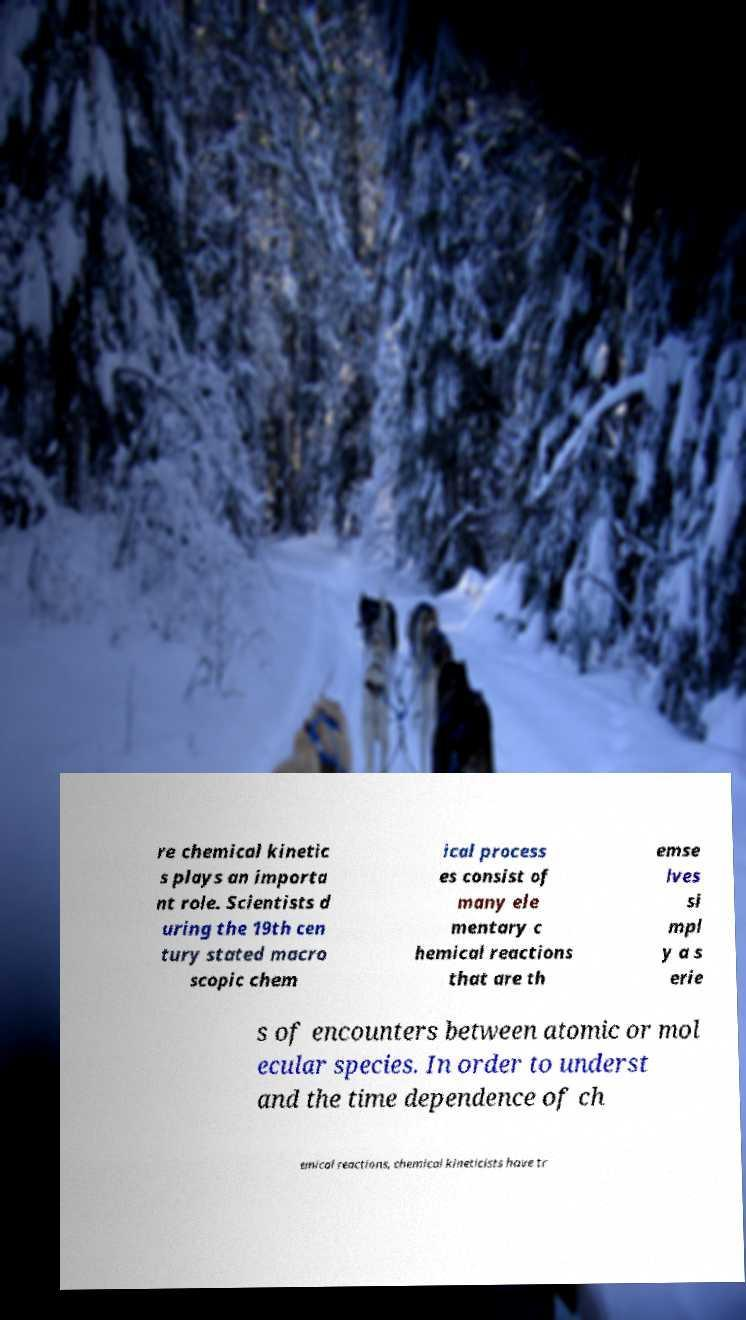Could you extract and type out the text from this image? re chemical kinetic s plays an importa nt role. Scientists d uring the 19th cen tury stated macro scopic chem ical process es consist of many ele mentary c hemical reactions that are th emse lves si mpl y a s erie s of encounters between atomic or mol ecular species. In order to underst and the time dependence of ch emical reactions, chemical kineticists have tr 